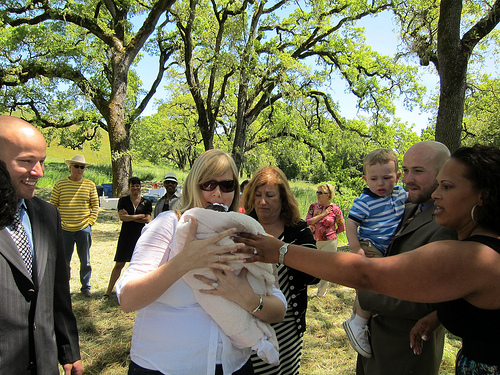<image>
Is there a woman on the child? No. The woman is not positioned on the child. They may be near each other, but the woman is not supported by or resting on top of the child. Is the man to the left of the women? No. The man is not to the left of the women. From this viewpoint, they have a different horizontal relationship. Is the woman behind the man? No. The woman is not behind the man. From this viewpoint, the woman appears to be positioned elsewhere in the scene. Is the women next to the tree? No. The women is not positioned next to the tree. They are located in different areas of the scene. Is the tree in front of the woman? No. The tree is not in front of the woman. The spatial positioning shows a different relationship between these objects. 